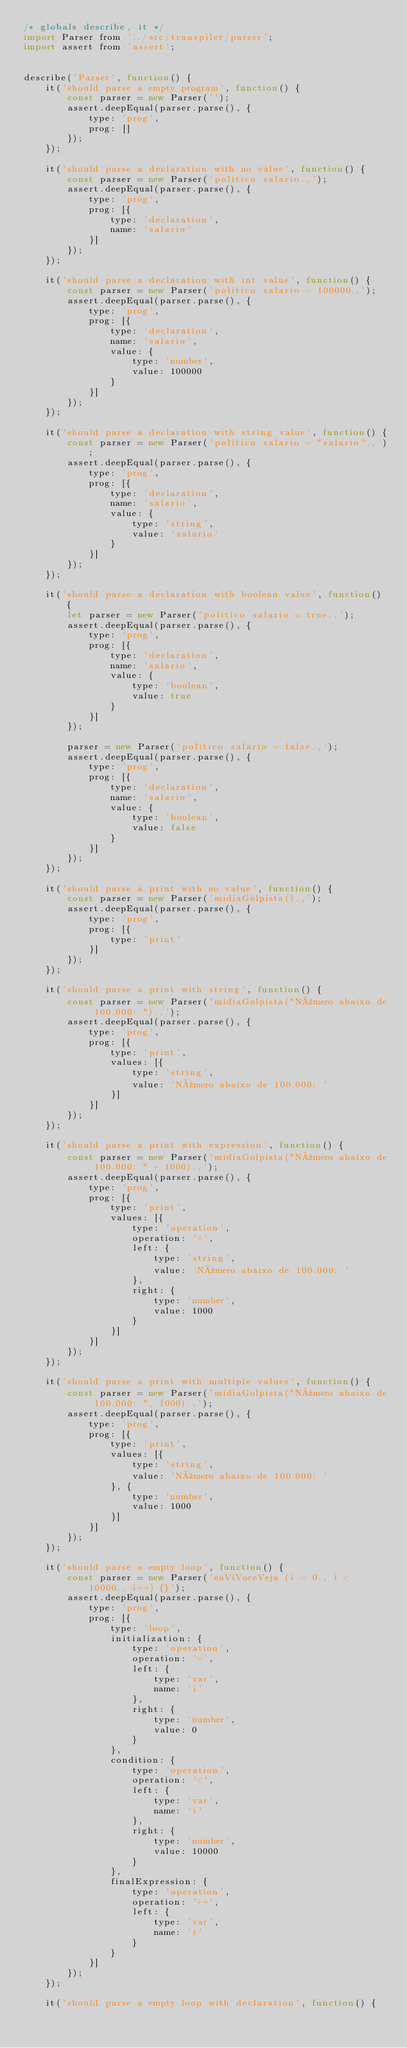Convert code to text. <code><loc_0><loc_0><loc_500><loc_500><_JavaScript_>/* globals describe, it */
import Parser from '../src/transpiler/parser';
import assert from 'assert';


describe('Parser', function() {
	it('should parse a empty program', function() {
		const parser = new Parser('');
		assert.deepEqual(parser.parse(), {
			type: 'prog',
			prog: []
		});
	});

	it('should parse a declaration with no value', function() {
		const parser = new Parser('politico salario.,');
		assert.deepEqual(parser.parse(), {
			type: 'prog',
			prog: [{
				type: 'declaration',
				name: 'salario'
			}]
		});
	});

	it('should parse a declaration with int value', function() {
		const parser = new Parser('politico salario = 100000.,');
		assert.deepEqual(parser.parse(), {
			type: 'prog',
			prog: [{
				type: 'declaration',
				name: 'salario',
				value: {
					type: 'number',
					value: 100000
				}
			}]
		});
	});

	it('should parse a declaration with string value', function() {
		const parser = new Parser('politico salario = "salario".,');
		assert.deepEqual(parser.parse(), {
			type: 'prog',
			prog: [{
				type: 'declaration',
				name: 'salario',
				value: {
					type: 'string',
					value: 'salario'
				}
			}]
		});
	});

	it('should parse a declaration with boolean value', function() {
		let parser = new Parser('politico salario = true.,');
		assert.deepEqual(parser.parse(), {
			type: 'prog',
			prog: [{
				type: 'declaration',
				name: 'salario',
				value: {
					type: 'boolean',
					value: true
				}
			}]
		});

		parser = new Parser('politico salario = false.,');
		assert.deepEqual(parser.parse(), {
			type: 'prog',
			prog: [{
				type: 'declaration',
				name: 'salario',
				value: {
					type: 'boolean',
					value: false
				}
			}]
		});
	});

	it('should parse a print with no value', function() {
		const parser = new Parser('midiaGolpista().,');
		assert.deepEqual(parser.parse(), {
			type: 'prog',
			prog: [{
				type: 'print'
			}]
		});
	});

	it('should parse a print with string', function() {
		const parser = new Parser('midiaGolpista("Número abaixo de 100.000: ").,');
		assert.deepEqual(parser.parse(), {
			type: 'prog',
			prog: [{
				type: 'print',
				values: [{
					type: 'string',
					value: 'Número abaixo de 100.000: '
				}]
			}]
		});
	});

	it('should parse a print with expression', function() {
		const parser = new Parser('midiaGolpista("Número abaixo de 100.000: " + 1000).,');
		assert.deepEqual(parser.parse(), {
			type: 'prog',
			prog: [{
				type: 'print',
				values: [{
					type: 'operation',
					operation: '+',
					left: {
						type: 'string',
						value: 'Número abaixo de 100.000: '
					},
					right: {
						type: 'number',
						value: 1000
					}
				}]
			}]
		});
	});

	it('should parse a print with multiple values', function() {
		const parser = new Parser('midiaGolpista("Número abaixo de 100.000: ", 1000).,');
		assert.deepEqual(parser.parse(), {
			type: 'prog',
			prog: [{
				type: 'print',
				values: [{
					type: 'string',
					value: 'Número abaixo de 100.000: '
				}, {
					type: 'number',
					value: 1000
				}]
			}]
		});
	});

	it('should parse a empty loop', function() {
		const parser = new Parser('euViVoceVeja (i = 0., i < 10000., i++) {}');
		assert.deepEqual(parser.parse(), {
			type: 'prog',
			prog: [{
				type: 'loop',
				initialization: {
					type: 'operation',
					operation: '=',
					left: {
						type: 'var',
						name: 'i'
					},
					right: {
						type: 'number',
						value: 0
					}
				},
				condition: {
					type: 'operation',
					operation: '<',
					left: {
						type: 'var',
						name: 'i'
					},
					right: {
						type: 'number',
						value: 10000
					}
				},
				finalExpression: {
					type: 'operation',
					operation: '++',
					left: {
						type: 'var',
						name: 'i'
					}
				}
			}]
		});
	});

	it('should parse a empty loop with declaration', function() {</code> 